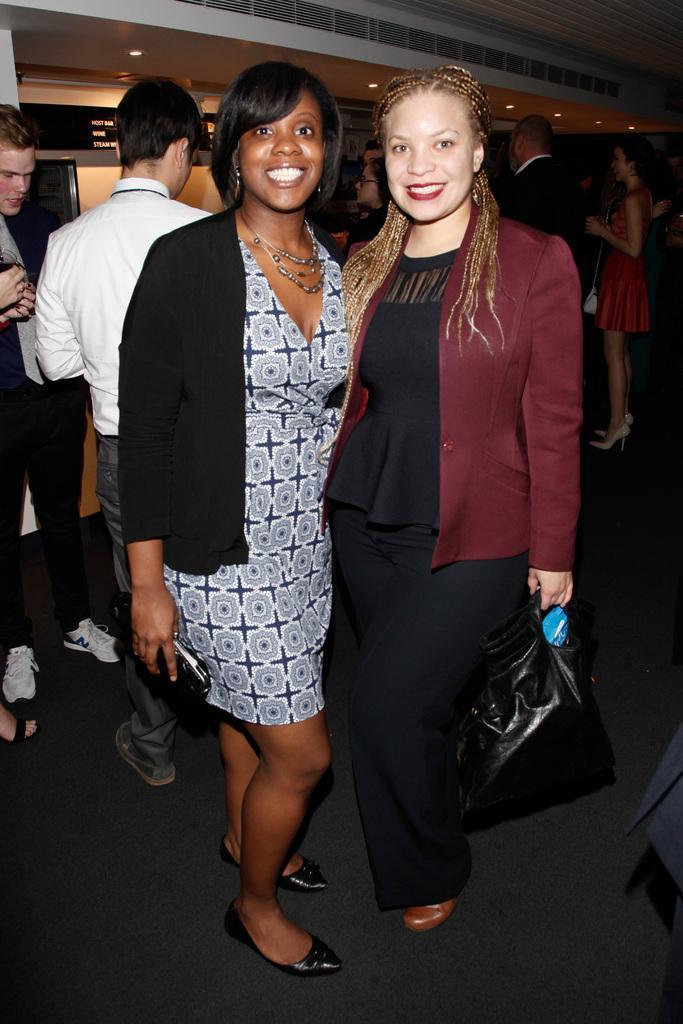Could you give a brief overview of what you see in this image? This picture shows few people standing and we see couple of women and we see a woman holding a handbag in her hand and another woman holding a wallet in her hand and we see smile on their faces and lights to the ceiling. 